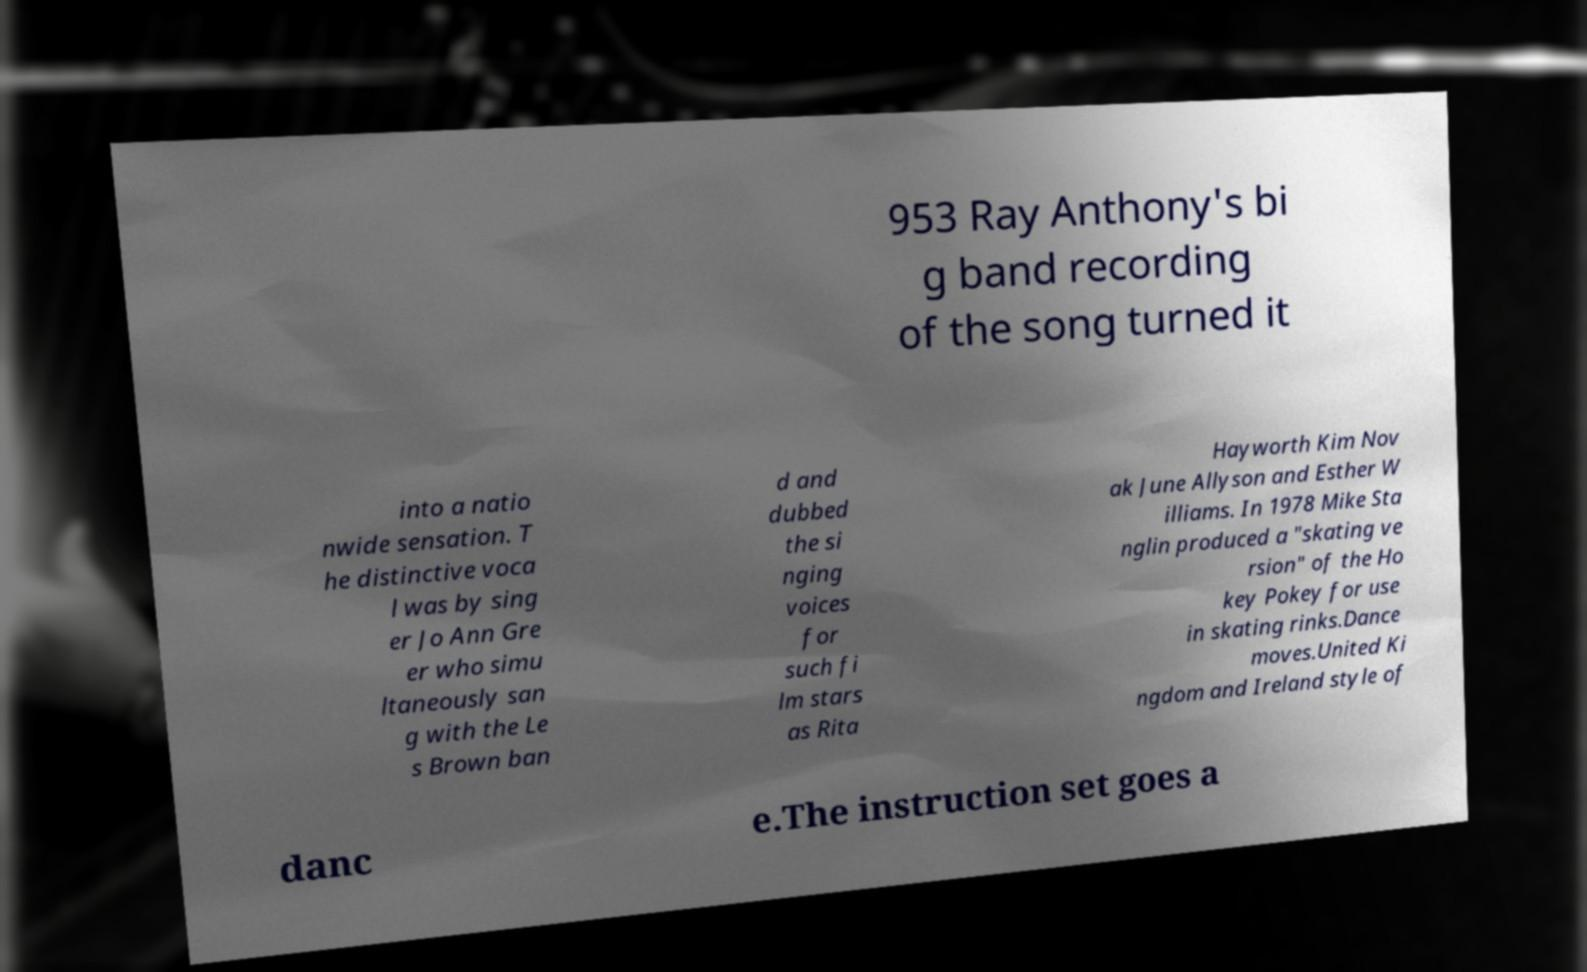Please read and relay the text visible in this image. What does it say? 953 Ray Anthony's bi g band recording of the song turned it into a natio nwide sensation. T he distinctive voca l was by sing er Jo Ann Gre er who simu ltaneously san g with the Le s Brown ban d and dubbed the si nging voices for such fi lm stars as Rita Hayworth Kim Nov ak June Allyson and Esther W illiams. In 1978 Mike Sta nglin produced a "skating ve rsion" of the Ho key Pokey for use in skating rinks.Dance moves.United Ki ngdom and Ireland style of danc e.The instruction set goes a 